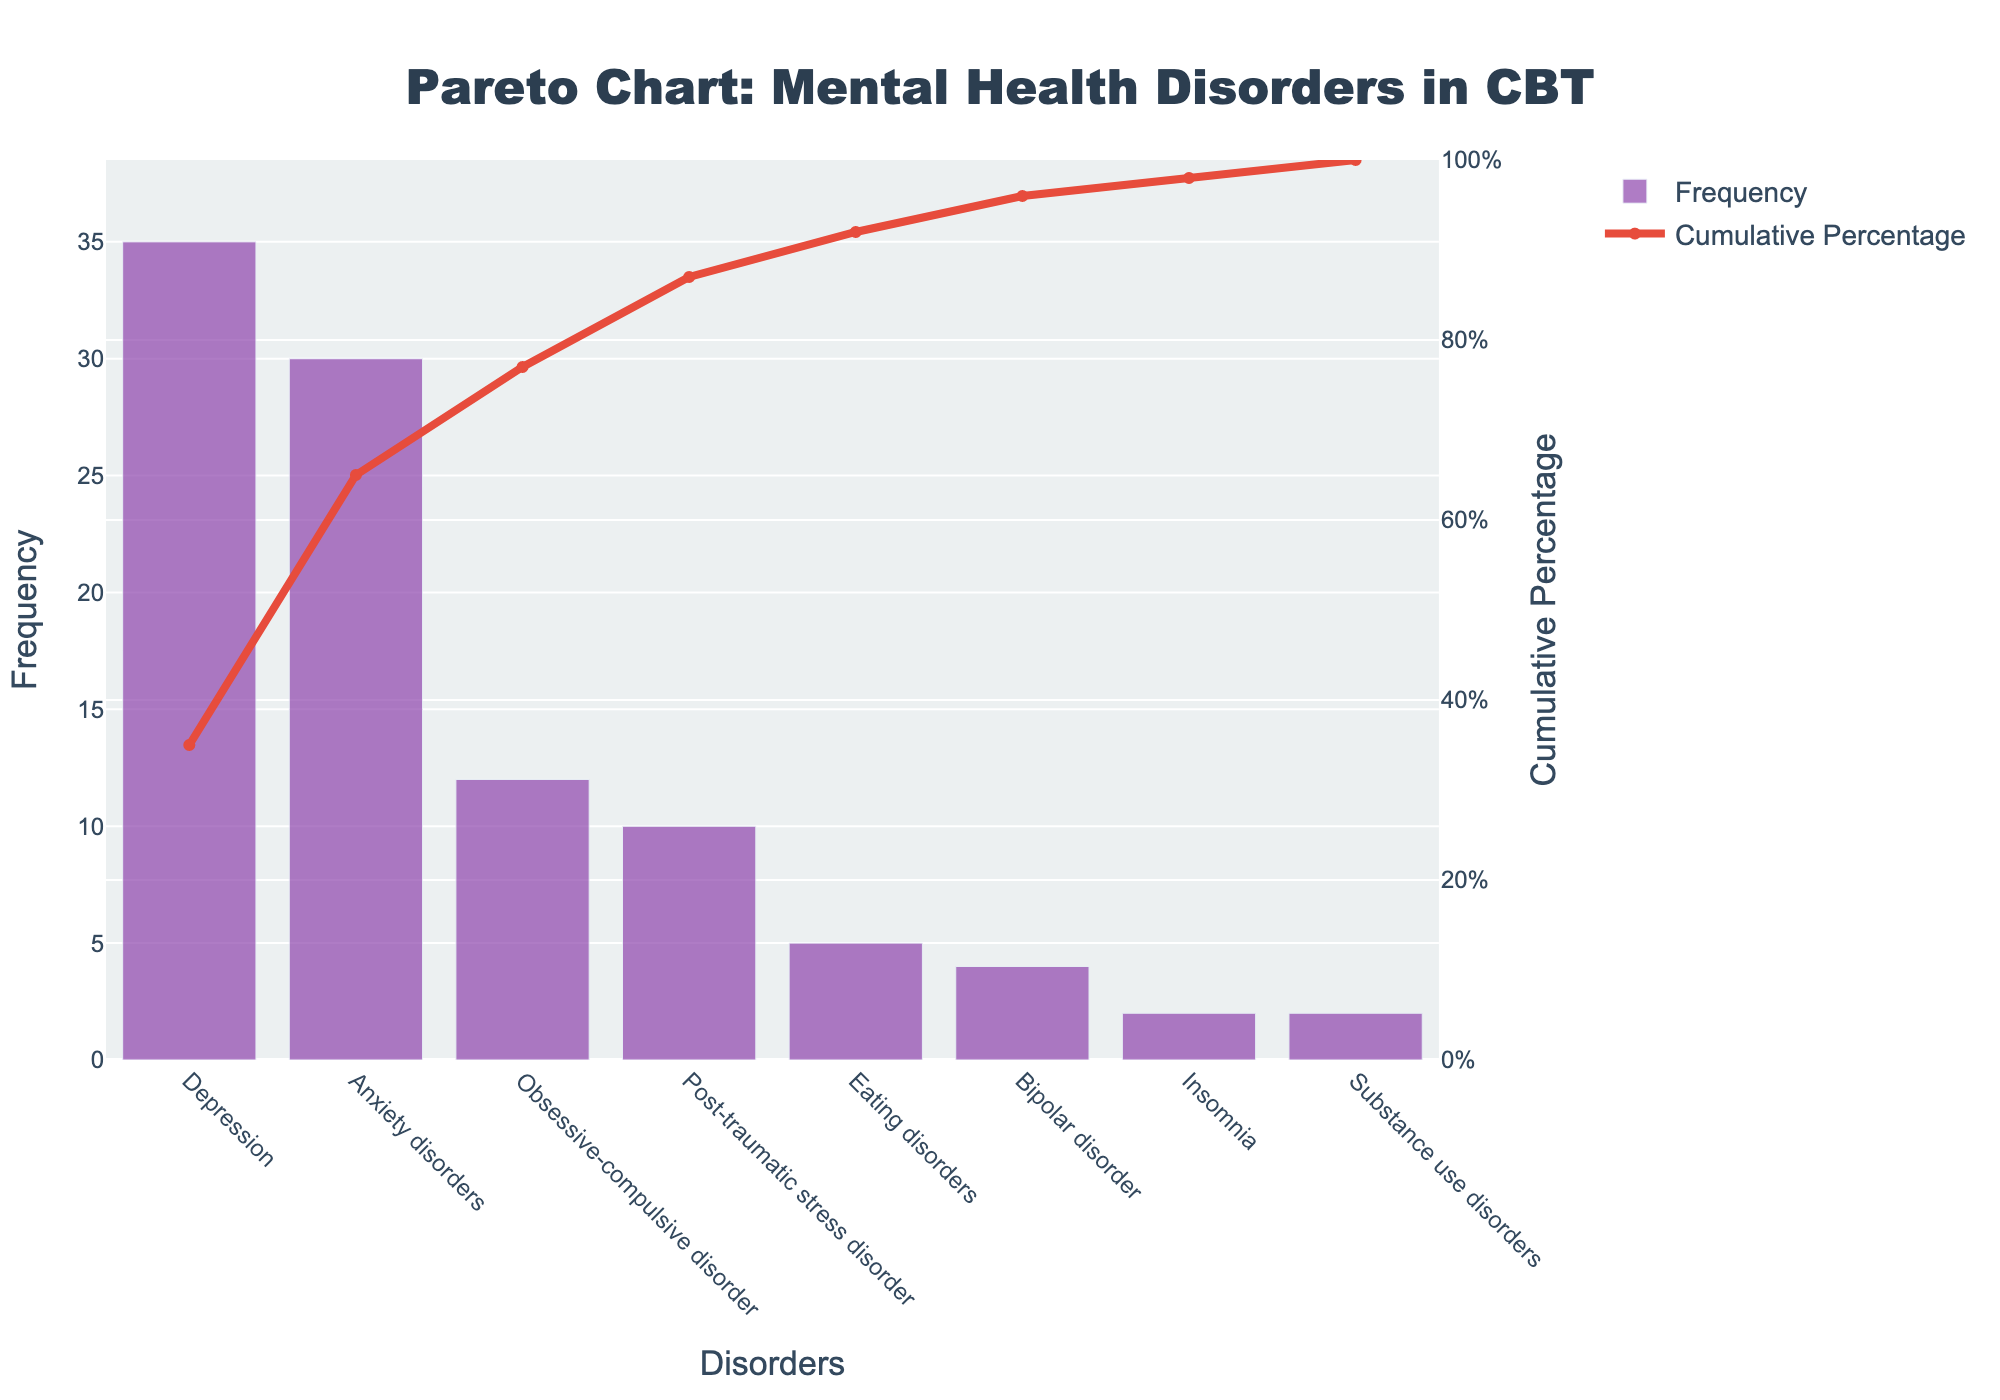what is the most common mental health disorder treated in CBT according to the pareto chart? The disorder with the highest frequency bar on the chart is Depression, sitting at the top of the ranked list.
Answer: Depression What is the total frequency of disorders that have a cumulative percentage over 50%? Add the frequencies of Depression and Anxiety Disorders: 35 (Depression) + 30 (Anxiety Disorders) to get the total frequency.
Answer: 65 What is the cumulative percentage for Obsessive-compulsive disorder? The cumulative line corresponding to Obsessive-compulsive disorder sits at a point just below 80% on the Y-axis.
Answer: Around 77% How many disorders have a frequency of 5 or less? Based on the bar lengths and labels, Eating Disorders, Bipolar Disorder, Insomnia, and Substance Use Disorders all have frequencies of 5 or less.
Answer: 4 Which disorder has a higher frequency: Post-traumatic stress disorder or Eating disorders? By comparing the heights of their bars, Post-traumatic stress disorder (10) is higher than Eating disorders (5).
Answer: Post-traumatic stress disorder What's the cumulative percentage after including Eating disorders? The cumulative percentage line for Eating disorders is between 90% and 95%, closer to 92%.
Answer: Around 92% What is the frequency range visible on the primary Y-axis of this Pareto chart? The frequency Y-axis starts at 0 and ends just above the highest bar which is Depression at 35, extending to around 40.
Answer: 0 to 40 Considering cumulative percentages, what percentage of total treatments does Bipolar disorder contribute? By looking at the cumulative percentage line associated with Bipolar disorder, it is between 95% and 100%, around 98%.
Answer: Around 98% Which disorder's frequency causes the cumulative percentage to surpass 80% for the first time? The cumulative percentage surpasses 80% after Obsessive-compulsive disorder is included in the tally.
Answer: Obsessive-compulsive disorder 